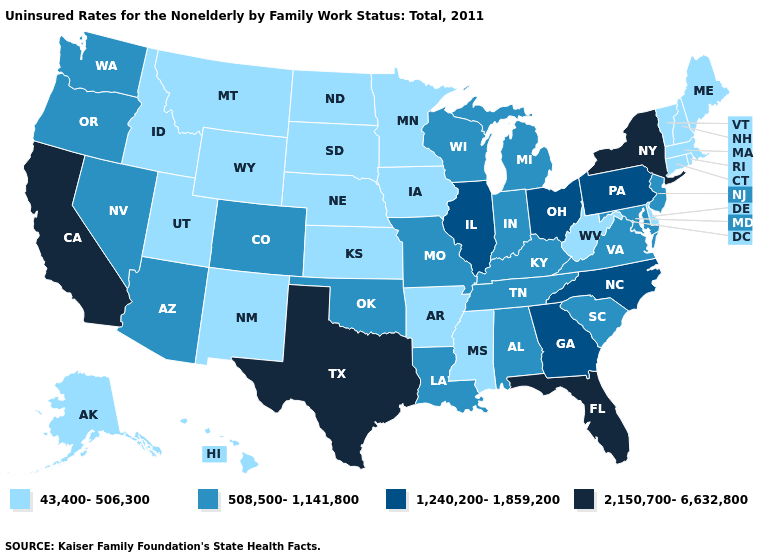What is the value of Montana?
Short answer required. 43,400-506,300. Name the states that have a value in the range 508,500-1,141,800?
Be succinct. Alabama, Arizona, Colorado, Indiana, Kentucky, Louisiana, Maryland, Michigan, Missouri, Nevada, New Jersey, Oklahoma, Oregon, South Carolina, Tennessee, Virginia, Washington, Wisconsin. Among the states that border Florida , which have the highest value?
Answer briefly. Georgia. Among the states that border Alabama , which have the lowest value?
Be succinct. Mississippi. Name the states that have a value in the range 43,400-506,300?
Write a very short answer. Alaska, Arkansas, Connecticut, Delaware, Hawaii, Idaho, Iowa, Kansas, Maine, Massachusetts, Minnesota, Mississippi, Montana, Nebraska, New Hampshire, New Mexico, North Dakota, Rhode Island, South Dakota, Utah, Vermont, West Virginia, Wyoming. What is the highest value in states that border North Dakota?
Answer briefly. 43,400-506,300. Among the states that border North Carolina , does Tennessee have the lowest value?
Short answer required. Yes. Name the states that have a value in the range 508,500-1,141,800?
Be succinct. Alabama, Arizona, Colorado, Indiana, Kentucky, Louisiana, Maryland, Michigan, Missouri, Nevada, New Jersey, Oklahoma, Oregon, South Carolina, Tennessee, Virginia, Washington, Wisconsin. Which states have the highest value in the USA?
Write a very short answer. California, Florida, New York, Texas. Name the states that have a value in the range 2,150,700-6,632,800?
Be succinct. California, Florida, New York, Texas. Name the states that have a value in the range 2,150,700-6,632,800?
Concise answer only. California, Florida, New York, Texas. What is the value of South Carolina?
Concise answer only. 508,500-1,141,800. What is the highest value in the South ?
Keep it brief. 2,150,700-6,632,800. Name the states that have a value in the range 508,500-1,141,800?
Short answer required. Alabama, Arizona, Colorado, Indiana, Kentucky, Louisiana, Maryland, Michigan, Missouri, Nevada, New Jersey, Oklahoma, Oregon, South Carolina, Tennessee, Virginia, Washington, Wisconsin. How many symbols are there in the legend?
Short answer required. 4. 